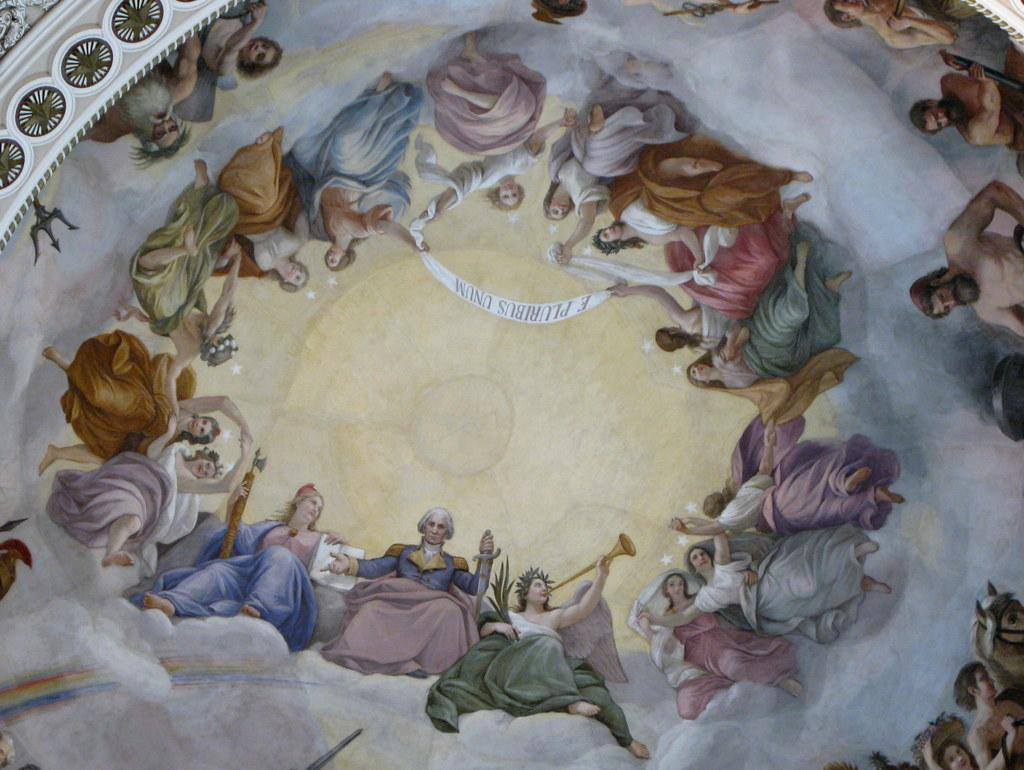What is on the ceiling wall in the image? There is a painting on the ceiling wall in the image. What is the subject matter of the painting? The painting depicts women and men. What are the women in the painting wearing? The women in the painting are wearing dresses. What are the women holding in the painting? The women in the painting are holding a ribbon. What type of comfort can be seen in the painting? There is no reference to comfort in the painting; it depicts women and men wearing dresses and holding a ribbon. What kind of breakfast is being served in the painting? There is no breakfast depicted in the painting; it focuses on the people and their attire. 